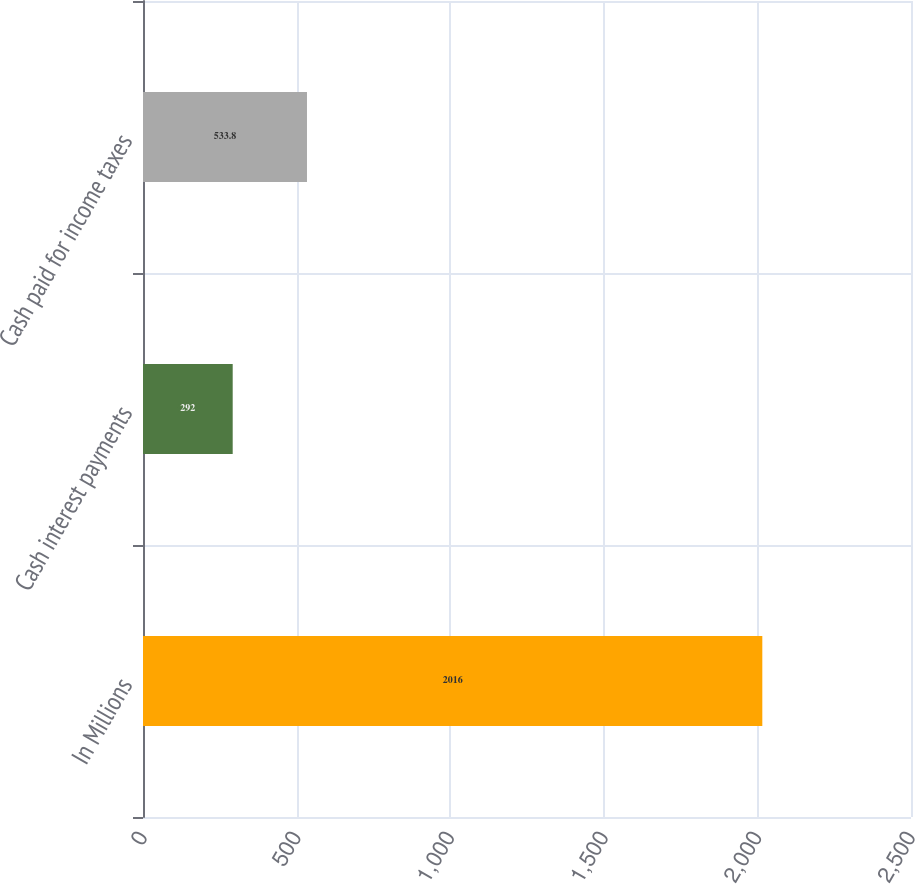Convert chart. <chart><loc_0><loc_0><loc_500><loc_500><bar_chart><fcel>In Millions<fcel>Cash interest payments<fcel>Cash paid for income taxes<nl><fcel>2016<fcel>292<fcel>533.8<nl></chart> 